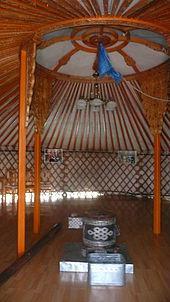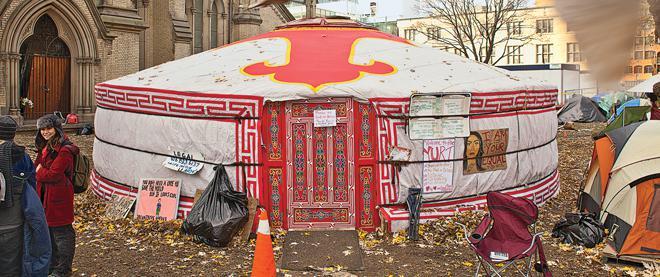The first image is the image on the left, the second image is the image on the right. Given the left and right images, does the statement "One image shows the interior of a yurt with at least two support beams and latticed walls, with a light fixture hanging from the center of the ceiling." hold true? Answer yes or no. Yes. The first image is the image on the left, the second image is the image on the right. Considering the images on both sides, is "The right image contains at least one human being." valid? Answer yes or no. Yes. 